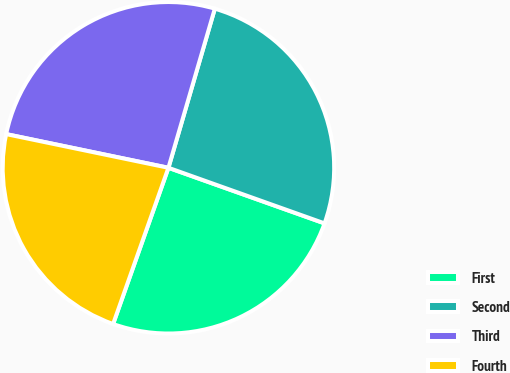Convert chart. <chart><loc_0><loc_0><loc_500><loc_500><pie_chart><fcel>First<fcel>Second<fcel>Third<fcel>Fourth<nl><fcel>24.97%<fcel>25.93%<fcel>26.26%<fcel>22.84%<nl></chart> 